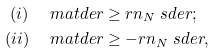Convert formula to latex. <formula><loc_0><loc_0><loc_500><loc_500>( i ) & \quad \ m a t d e r \geq r n _ { N } \ s d e r ; \\ ( i i ) & \quad \ m a t d e r \geq - r n _ { N } \ s d e r ,</formula> 